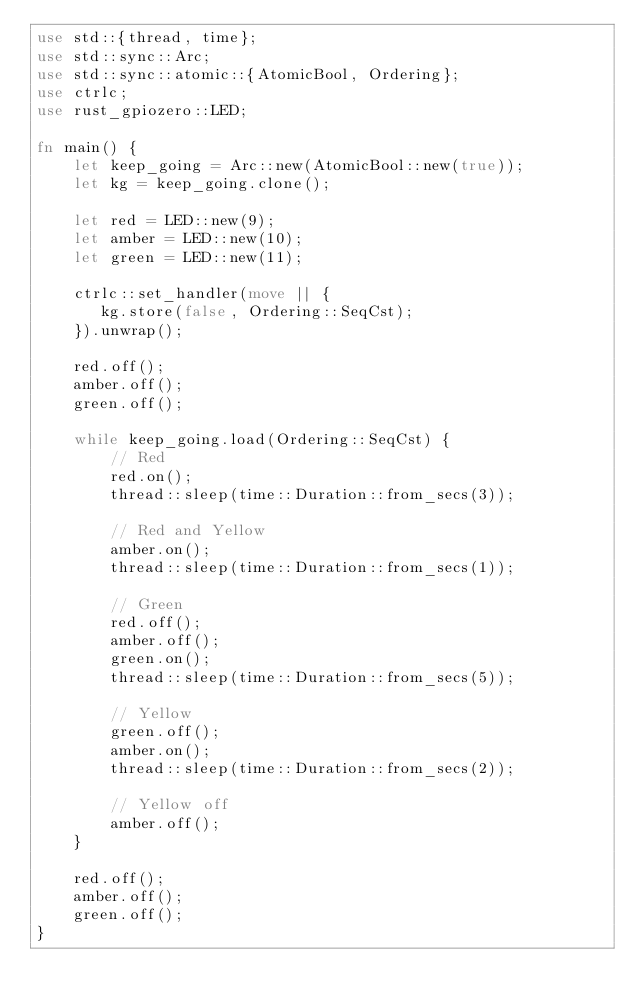<code> <loc_0><loc_0><loc_500><loc_500><_Rust_>use std::{thread, time};
use std::sync::Arc;
use std::sync::atomic::{AtomicBool, Ordering};
use ctrlc;
use rust_gpiozero::LED;

fn main() {
    let keep_going = Arc::new(AtomicBool::new(true));
    let kg = keep_going.clone();

    let red = LED::new(9);
    let amber = LED::new(10);
    let green = LED::new(11);

    ctrlc::set_handler(move || {
       kg.store(false, Ordering::SeqCst);
    }).unwrap();

    red.off();
    amber.off();
    green.off();

    while keep_going.load(Ordering::SeqCst) {
        // Red
        red.on();
        thread::sleep(time::Duration::from_secs(3));

        // Red and Yellow
        amber.on();
        thread::sleep(time::Duration::from_secs(1));

        // Green
        red.off();
        amber.off();
        green.on();
        thread::sleep(time::Duration::from_secs(5));

        // Yellow
        green.off();
        amber.on();
        thread::sleep(time::Duration::from_secs(2));

        // Yellow off
        amber.off();
    }

    red.off();
    amber.off();
    green.off();
}
</code> 